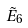<formula> <loc_0><loc_0><loc_500><loc_500>\tilde { E } _ { 6 }</formula> 